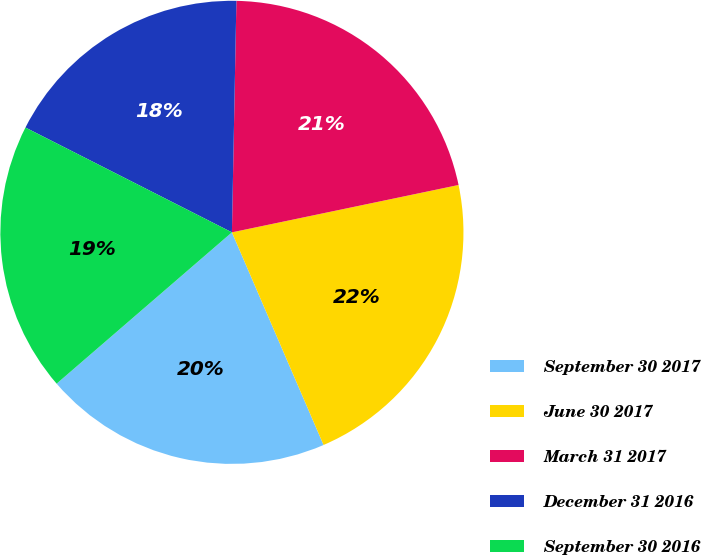Convert chart to OTSL. <chart><loc_0><loc_0><loc_500><loc_500><pie_chart><fcel>September 30 2017<fcel>June 30 2017<fcel>March 31 2017<fcel>December 31 2016<fcel>September 30 2016<nl><fcel>20.14%<fcel>21.8%<fcel>21.41%<fcel>17.83%<fcel>18.81%<nl></chart> 